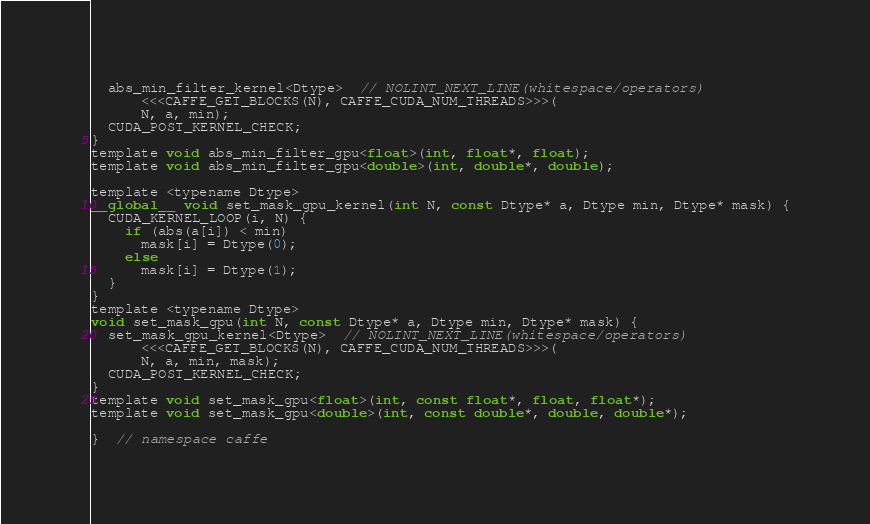Convert code to text. <code><loc_0><loc_0><loc_500><loc_500><_Cuda_>  abs_min_filter_kernel<Dtype>  // NOLINT_NEXT_LINE(whitespace/operators)
      <<<CAFFE_GET_BLOCKS(N), CAFFE_CUDA_NUM_THREADS>>>(
      N, a, min);
  CUDA_POST_KERNEL_CHECK;
}
template void abs_min_filter_gpu<float>(int, float*, float);
template void abs_min_filter_gpu<double>(int, double*, double);

template <typename Dtype>
__global__ void set_mask_gpu_kernel(int N, const Dtype* a, Dtype min, Dtype* mask) {
  CUDA_KERNEL_LOOP(i, N) {
    if (abs(a[i]) < min)
      mask[i] = Dtype(0);
    else
      mask[i] = Dtype(1);
  }
}
template <typename Dtype>
void set_mask_gpu(int N, const Dtype* a, Dtype min, Dtype* mask) {
  set_mask_gpu_kernel<Dtype>  // NOLINT_NEXT_LINE(whitespace/operators)
      <<<CAFFE_GET_BLOCKS(N), CAFFE_CUDA_NUM_THREADS>>>(
      N, a, min, mask);
  CUDA_POST_KERNEL_CHECK;
}
template void set_mask_gpu<float>(int, const float*, float, float*);
template void set_mask_gpu<double>(int, const double*, double, double*);

}  // namespace caffe
</code> 